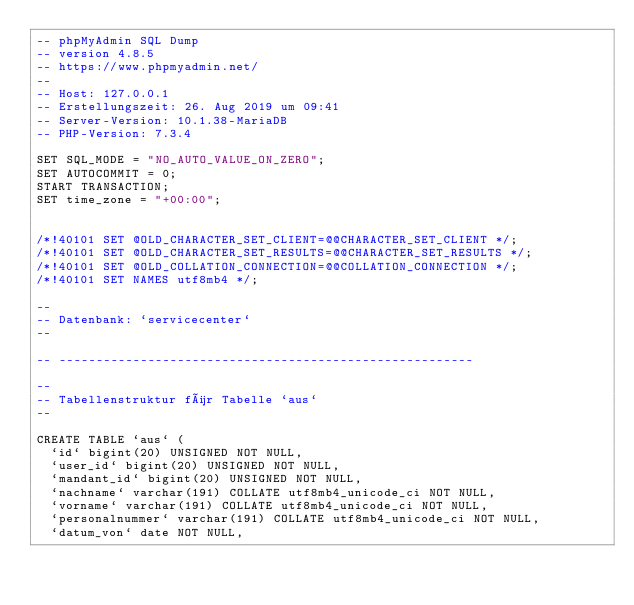<code> <loc_0><loc_0><loc_500><loc_500><_SQL_>-- phpMyAdmin SQL Dump
-- version 4.8.5
-- https://www.phpmyadmin.net/
--
-- Host: 127.0.0.1
-- Erstellungszeit: 26. Aug 2019 um 09:41
-- Server-Version: 10.1.38-MariaDB
-- PHP-Version: 7.3.4

SET SQL_MODE = "NO_AUTO_VALUE_ON_ZERO";
SET AUTOCOMMIT = 0;
START TRANSACTION;
SET time_zone = "+00:00";


/*!40101 SET @OLD_CHARACTER_SET_CLIENT=@@CHARACTER_SET_CLIENT */;
/*!40101 SET @OLD_CHARACTER_SET_RESULTS=@@CHARACTER_SET_RESULTS */;
/*!40101 SET @OLD_COLLATION_CONNECTION=@@COLLATION_CONNECTION */;
/*!40101 SET NAMES utf8mb4 */;

--
-- Datenbank: `servicecenter`
--

-- --------------------------------------------------------

--
-- Tabellenstruktur für Tabelle `aus`
--

CREATE TABLE `aus` (
  `id` bigint(20) UNSIGNED NOT NULL,
  `user_id` bigint(20) UNSIGNED NOT NULL,
  `mandant_id` bigint(20) UNSIGNED NOT NULL,
  `nachname` varchar(191) COLLATE utf8mb4_unicode_ci NOT NULL,
  `vorname` varchar(191) COLLATE utf8mb4_unicode_ci NOT NULL,
  `personalnummer` varchar(191) COLLATE utf8mb4_unicode_ci NOT NULL,
  `datum_von` date NOT NULL,</code> 